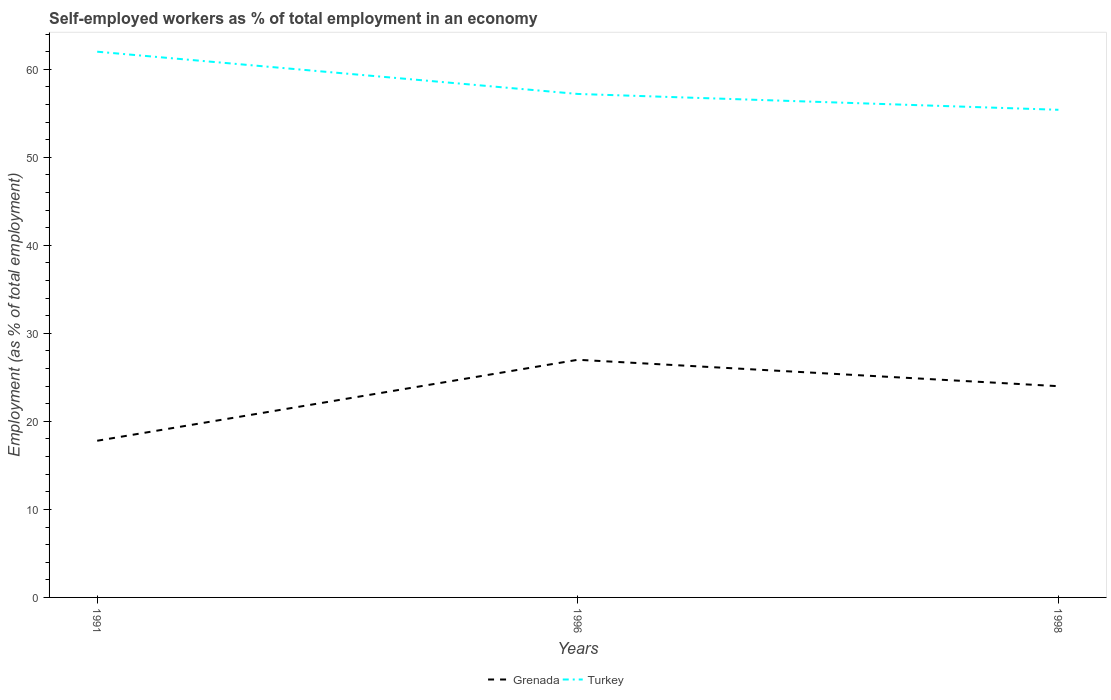How many different coloured lines are there?
Your response must be concise. 2. Does the line corresponding to Turkey intersect with the line corresponding to Grenada?
Provide a succinct answer. No. Is the number of lines equal to the number of legend labels?
Provide a short and direct response. Yes. Across all years, what is the maximum percentage of self-employed workers in Turkey?
Your response must be concise. 55.4. What is the total percentage of self-employed workers in Turkey in the graph?
Offer a very short reply. 1.8. What is the difference between the highest and the second highest percentage of self-employed workers in Turkey?
Offer a very short reply. 6.6. What is the difference between the highest and the lowest percentage of self-employed workers in Grenada?
Provide a succinct answer. 2. Is the percentage of self-employed workers in Turkey strictly greater than the percentage of self-employed workers in Grenada over the years?
Keep it short and to the point. No. How many lines are there?
Provide a succinct answer. 2. Are the values on the major ticks of Y-axis written in scientific E-notation?
Keep it short and to the point. No. Does the graph contain any zero values?
Your answer should be very brief. No. Where does the legend appear in the graph?
Your response must be concise. Bottom center. What is the title of the graph?
Offer a very short reply. Self-employed workers as % of total employment in an economy. Does "Brunei Darussalam" appear as one of the legend labels in the graph?
Offer a terse response. No. What is the label or title of the X-axis?
Give a very brief answer. Years. What is the label or title of the Y-axis?
Give a very brief answer. Employment (as % of total employment). What is the Employment (as % of total employment) in Grenada in 1991?
Your answer should be compact. 17.8. What is the Employment (as % of total employment) in Turkey in 1996?
Provide a succinct answer. 57.2. What is the Employment (as % of total employment) of Turkey in 1998?
Your answer should be very brief. 55.4. Across all years, what is the maximum Employment (as % of total employment) of Turkey?
Offer a terse response. 62. Across all years, what is the minimum Employment (as % of total employment) in Grenada?
Keep it short and to the point. 17.8. Across all years, what is the minimum Employment (as % of total employment) in Turkey?
Your answer should be compact. 55.4. What is the total Employment (as % of total employment) in Grenada in the graph?
Offer a terse response. 68.8. What is the total Employment (as % of total employment) of Turkey in the graph?
Your answer should be very brief. 174.6. What is the difference between the Employment (as % of total employment) in Grenada in 1991 and that in 1996?
Provide a short and direct response. -9.2. What is the difference between the Employment (as % of total employment) in Turkey in 1991 and that in 1996?
Offer a terse response. 4.8. What is the difference between the Employment (as % of total employment) of Grenada in 1991 and that in 1998?
Offer a very short reply. -6.2. What is the difference between the Employment (as % of total employment) of Grenada in 1996 and that in 1998?
Ensure brevity in your answer.  3. What is the difference between the Employment (as % of total employment) in Turkey in 1996 and that in 1998?
Provide a short and direct response. 1.8. What is the difference between the Employment (as % of total employment) in Grenada in 1991 and the Employment (as % of total employment) in Turkey in 1996?
Provide a short and direct response. -39.4. What is the difference between the Employment (as % of total employment) of Grenada in 1991 and the Employment (as % of total employment) of Turkey in 1998?
Provide a succinct answer. -37.6. What is the difference between the Employment (as % of total employment) of Grenada in 1996 and the Employment (as % of total employment) of Turkey in 1998?
Offer a terse response. -28.4. What is the average Employment (as % of total employment) of Grenada per year?
Your answer should be compact. 22.93. What is the average Employment (as % of total employment) in Turkey per year?
Provide a succinct answer. 58.2. In the year 1991, what is the difference between the Employment (as % of total employment) of Grenada and Employment (as % of total employment) of Turkey?
Your response must be concise. -44.2. In the year 1996, what is the difference between the Employment (as % of total employment) of Grenada and Employment (as % of total employment) of Turkey?
Offer a very short reply. -30.2. In the year 1998, what is the difference between the Employment (as % of total employment) in Grenada and Employment (as % of total employment) in Turkey?
Make the answer very short. -31.4. What is the ratio of the Employment (as % of total employment) of Grenada in 1991 to that in 1996?
Your answer should be very brief. 0.66. What is the ratio of the Employment (as % of total employment) of Turkey in 1991 to that in 1996?
Provide a succinct answer. 1.08. What is the ratio of the Employment (as % of total employment) of Grenada in 1991 to that in 1998?
Give a very brief answer. 0.74. What is the ratio of the Employment (as % of total employment) in Turkey in 1991 to that in 1998?
Your response must be concise. 1.12. What is the ratio of the Employment (as % of total employment) in Turkey in 1996 to that in 1998?
Your response must be concise. 1.03. What is the difference between the highest and the second highest Employment (as % of total employment) of Turkey?
Keep it short and to the point. 4.8. What is the difference between the highest and the lowest Employment (as % of total employment) of Grenada?
Offer a terse response. 9.2. 